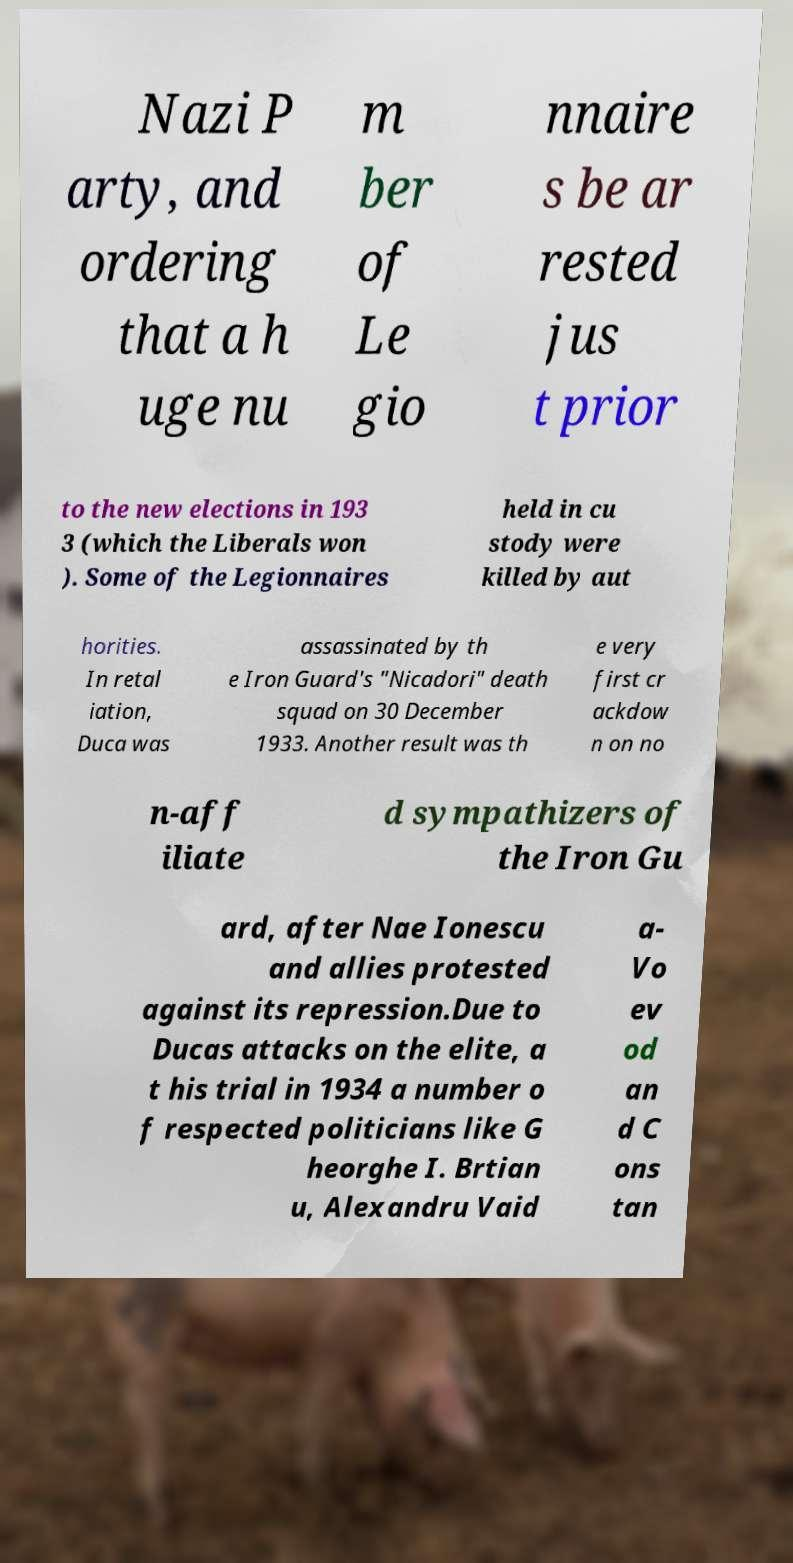Could you extract and type out the text from this image? Nazi P arty, and ordering that a h uge nu m ber of Le gio nnaire s be ar rested jus t prior to the new elections in 193 3 (which the Liberals won ). Some of the Legionnaires held in cu stody were killed by aut horities. In retal iation, Duca was assassinated by th e Iron Guard's "Nicadori" death squad on 30 December 1933. Another result was th e very first cr ackdow n on no n-aff iliate d sympathizers of the Iron Gu ard, after Nae Ionescu and allies protested against its repression.Due to Ducas attacks on the elite, a t his trial in 1934 a number o f respected politicians like G heorghe I. Brtian u, Alexandru Vaid a- Vo ev od an d C ons tan 